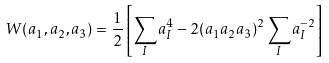Convert formula to latex. <formula><loc_0><loc_0><loc_500><loc_500>W ( a _ { 1 } , a _ { 2 } , a _ { 3 } ) = \frac { 1 } { 2 } \left [ \sum _ { I } a _ { I } ^ { 4 } - 2 ( a _ { 1 } a _ { 2 } a _ { 3 } ) ^ { 2 } \sum _ { I } a _ { I } ^ { - 2 } \right ]</formula> 